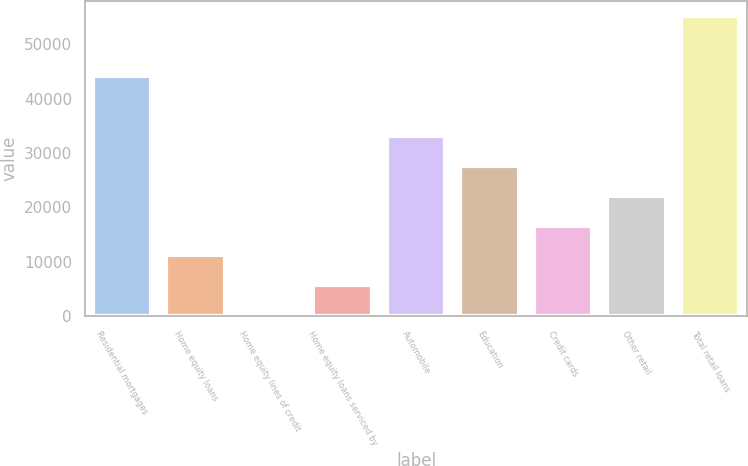<chart> <loc_0><loc_0><loc_500><loc_500><bar_chart><fcel>Residential mortgages<fcel>Home equity loans<fcel>Home equity lines of credit<fcel>Home equity loans serviced by<fcel>Automobile<fcel>Education<fcel>Credit cards<fcel>Other retail<fcel>Total retail loans<nl><fcel>44179.2<fcel>11131.8<fcel>116<fcel>5623.9<fcel>33163.4<fcel>27655.5<fcel>16639.7<fcel>22147.6<fcel>55195<nl></chart> 